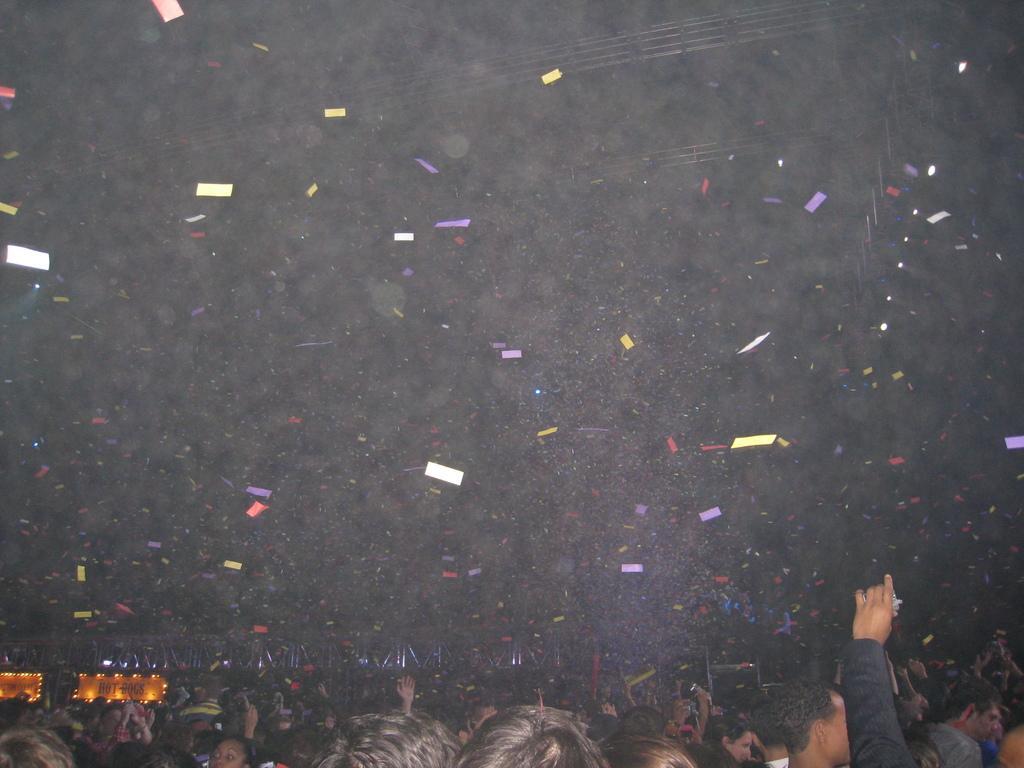In one or two sentences, can you explain what this image depicts? In the picture we can see public and they are throwing color papers in the air, in the background far away we can see a hoarding on the stage with lights. 